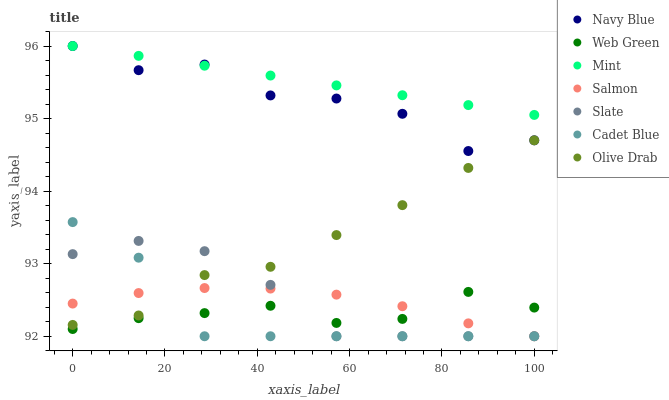Does Cadet Blue have the minimum area under the curve?
Answer yes or no. Yes. Does Mint have the maximum area under the curve?
Answer yes or no. Yes. Does Navy Blue have the minimum area under the curve?
Answer yes or no. No. Does Navy Blue have the maximum area under the curve?
Answer yes or no. No. Is Mint the smoothest?
Answer yes or no. Yes. Is Navy Blue the roughest?
Answer yes or no. Yes. Is Slate the smoothest?
Answer yes or no. No. Is Slate the roughest?
Answer yes or no. No. Does Cadet Blue have the lowest value?
Answer yes or no. Yes. Does Navy Blue have the lowest value?
Answer yes or no. No. Does Mint have the highest value?
Answer yes or no. Yes. Does Slate have the highest value?
Answer yes or no. No. Is Olive Drab less than Mint?
Answer yes or no. Yes. Is Mint greater than Web Green?
Answer yes or no. Yes. Does Cadet Blue intersect Salmon?
Answer yes or no. Yes. Is Cadet Blue less than Salmon?
Answer yes or no. No. Is Cadet Blue greater than Salmon?
Answer yes or no. No. Does Olive Drab intersect Mint?
Answer yes or no. No. 